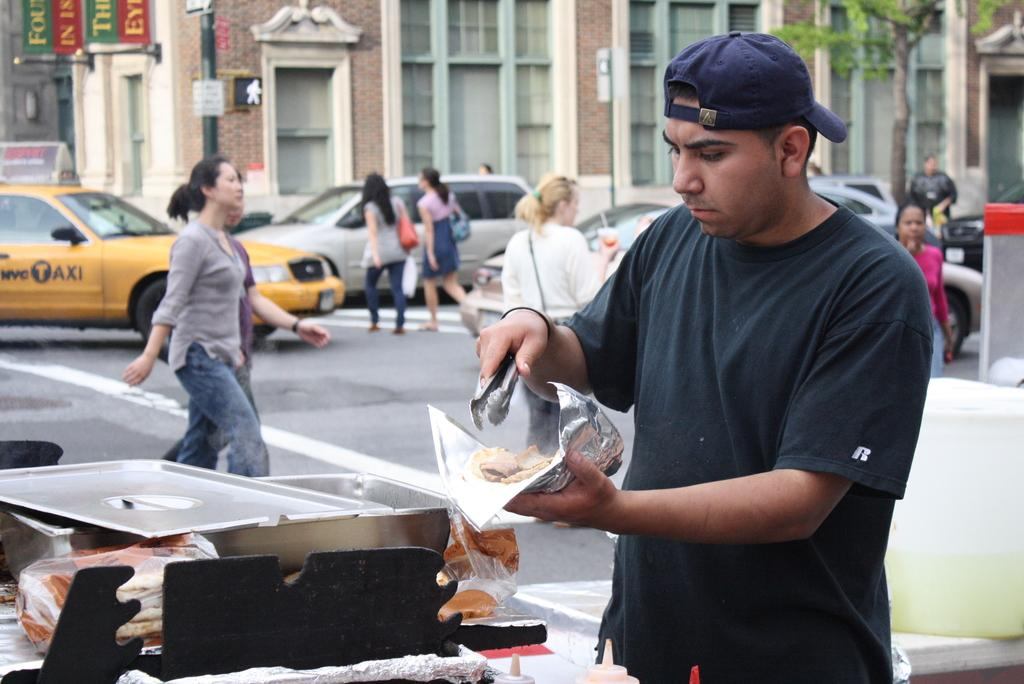<image>
Share a concise interpretation of the image provided. A man is using tongs to place food on a piece of foil, on the side of a street where a NYC Taxi is in the back ground. 